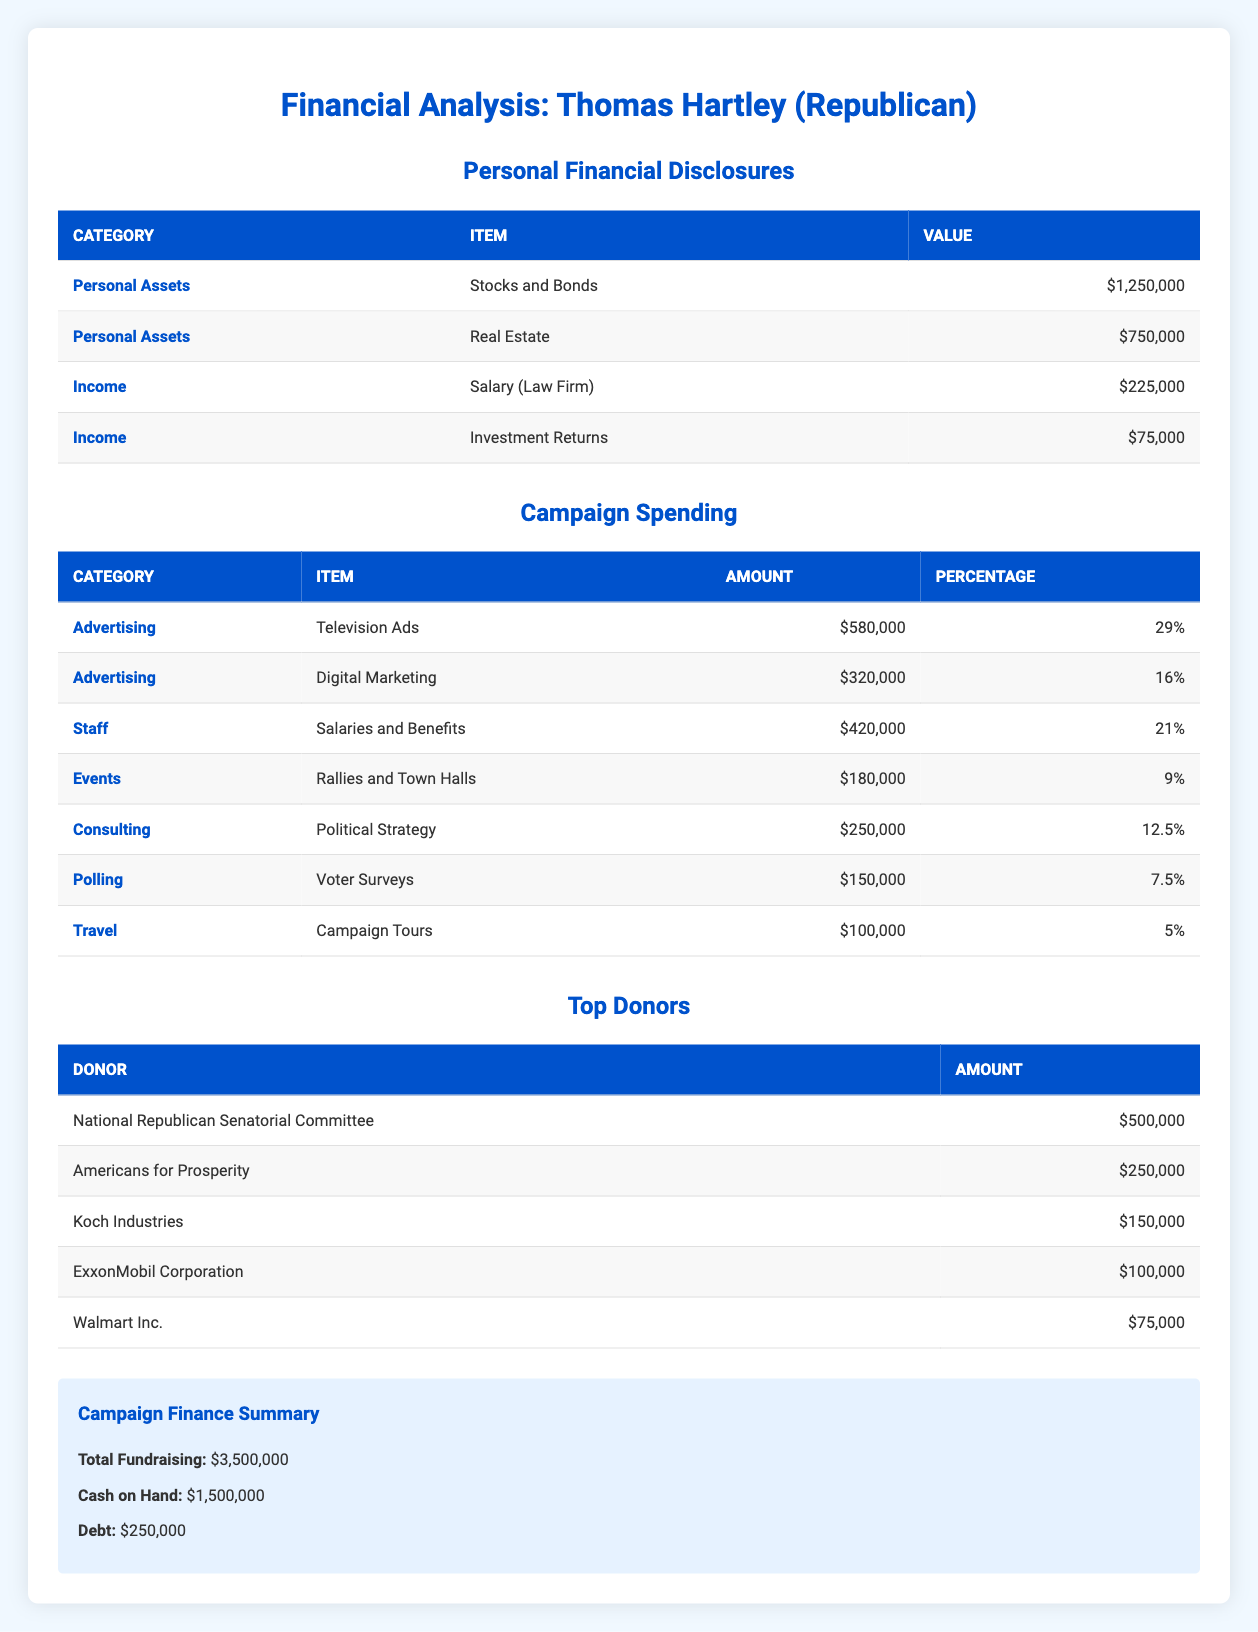What is the total amount listed for Thomas Hartley's Personal Assets? The Personal Assets category includes Stocks and Bonds valued at 1,250,000 and Real Estate valued at 750,000. Adding these together gives 1,250,000 + 750,000 = 2,000,000.
Answer: 2,000,000 Which category of campaign spending has the highest amount? From the campaign spending table, the Advertising category, specifically Television Ads, has the highest amount at 580,000.
Answer: Advertising (Television Ads) What percentage of campaign spending is allocated to Travel? The Travel category has an amount of 100,000 and a percentage of 5%. This information is directly found in the campaign spending table.
Answer: 5% Is the total fundraising greater than the total amount of cash on hand? The total fundraising amount is 3,500,000, and the cash on hand is 1,500,000. Since 3,500,000 is greater than 1,500,000, the statement is true.
Answer: Yes What is the combined total of the top two donors? The top two donors, National Republican Senatorial Committee and Americans for Prosperity, contribute 500,000 and 250,000 respectively. Adding these amounts gives 500,000 + 250,000 = 750,000.
Answer: 750,000 How much more does the opponent spend on Advertising compared to Travel? The opponent spends 580,000 on Advertising (Television Ads) and 100,000 on Travel. To find the difference, subtract the Travel spending from the Advertising spending: 580,000 - 100,000 = 480,000.
Answer: 480,000 What is the total income reported for Thomas Hartley? The income includes Salary (Law Firm) at 225,000 and Investment Returns at 75,000. Adding these together gives a total income of 225,000 + 75,000 = 300,000.
Answer: 300,000 Did the opponent report any debt? The table indicates a debt of 250,000. Thus, the answer to whether there is any reported debt is confirmed to be true.
Answer: Yes What percentage of the total fundraising is represented by the top donor? The top donor, National Republican Senatorial Committee, contributed 500,000 and the total fundraising is 3,500,000. To find the percentage, divide 500,000 by 3,500,000 and multiply by 100: (500,000 / 3,500,000) * 100 = 14.2857, approximately 14.29%.
Answer: 14.29% 